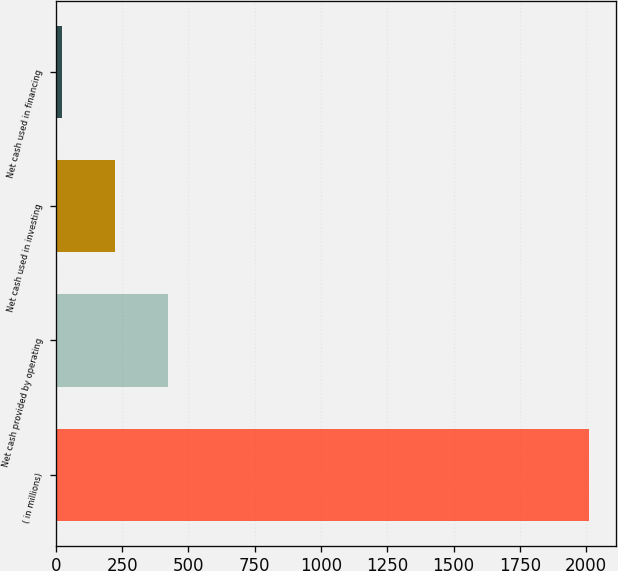Convert chart to OTSL. <chart><loc_0><loc_0><loc_500><loc_500><bar_chart><fcel>( in millions)<fcel>Net cash provided by operating<fcel>Net cash used in investing<fcel>Net cash used in financing<nl><fcel>2011<fcel>421.96<fcel>223.33<fcel>24.7<nl></chart> 